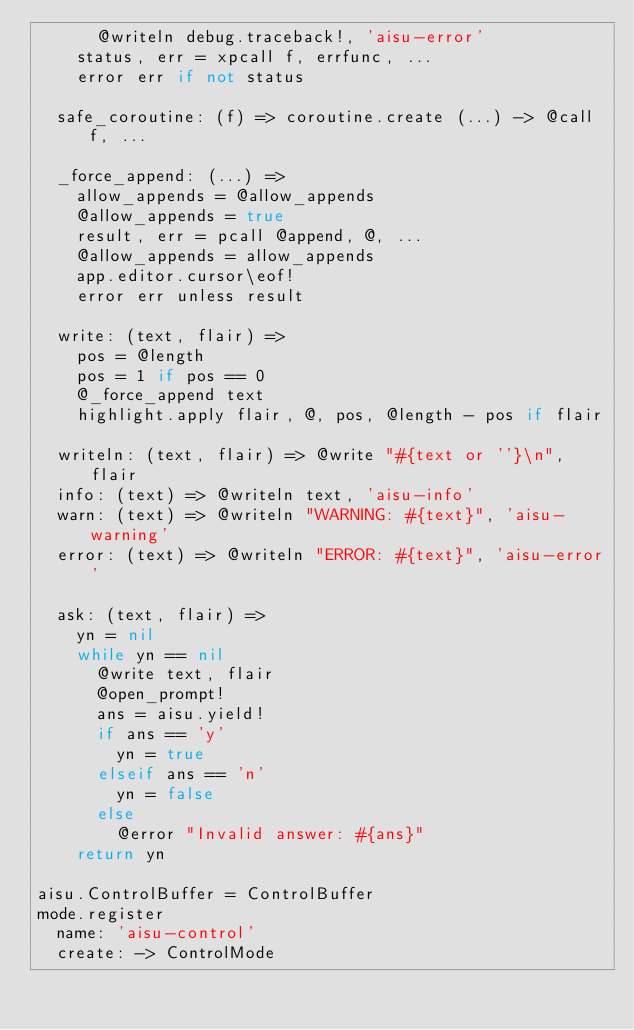<code> <loc_0><loc_0><loc_500><loc_500><_MoonScript_>      @writeln debug.traceback!, 'aisu-error'
    status, err = xpcall f, errfunc, ...
    error err if not status

  safe_coroutine: (f) => coroutine.create (...) -> @call f, ...

  _force_append: (...) =>
    allow_appends = @allow_appends
    @allow_appends = true
    result, err = pcall @append, @, ...
    @allow_appends = allow_appends
    app.editor.cursor\eof!
    error err unless result

  write: (text, flair) =>
    pos = @length
    pos = 1 if pos == 0
    @_force_append text
    highlight.apply flair, @, pos, @length - pos if flair

  writeln: (text, flair) => @write "#{text or ''}\n", flair
  info: (text) => @writeln text, 'aisu-info'
  warn: (text) => @writeln "WARNING: #{text}", 'aisu-warning'
  error: (text) => @writeln "ERROR: #{text}", 'aisu-error'

  ask: (text, flair) =>
    yn = nil
    while yn == nil
      @write text, flair
      @open_prompt!
      ans = aisu.yield!
      if ans == 'y'
        yn = true
      elseif ans == 'n'
        yn = false
      else
        @error "Invalid answer: #{ans}"
    return yn

aisu.ControlBuffer = ControlBuffer
mode.register
  name: 'aisu-control'
  create: -> ControlMode
</code> 